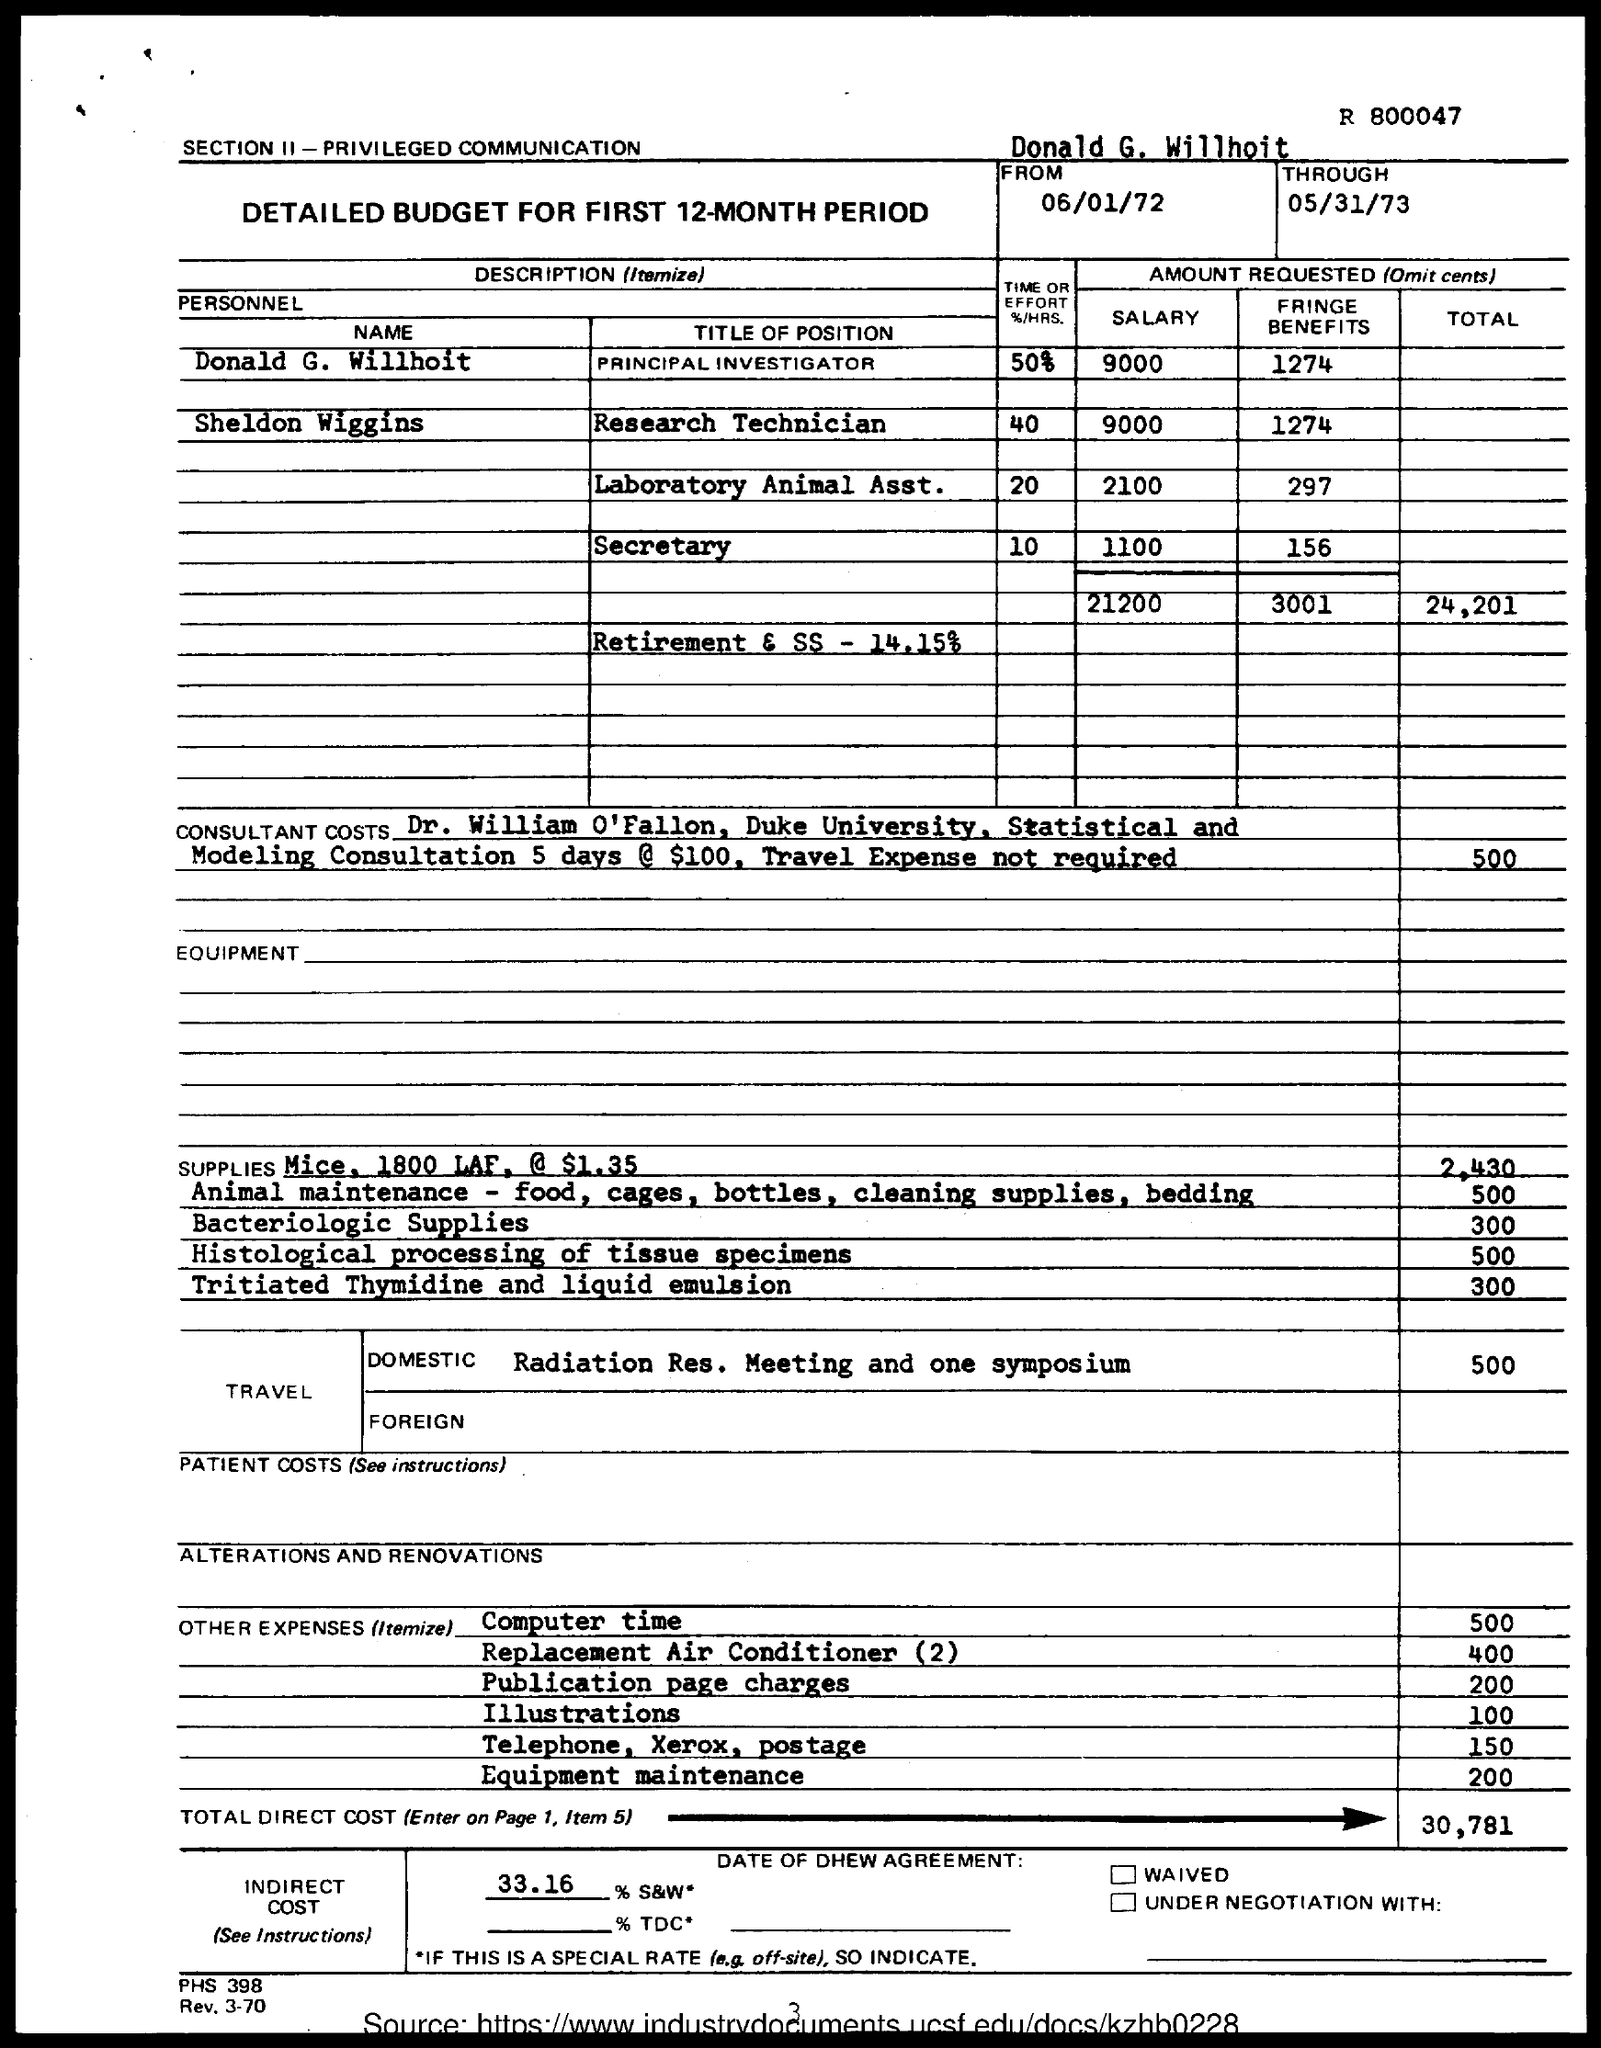Point out several critical features in this image. Sheldon Wiggins is a research technician. The second highest salary is for the position of Laboratory Animal Assistant, with an average annual salary of $65,000. Donald G. Willhoit is the principal investigator of a certain designation. 